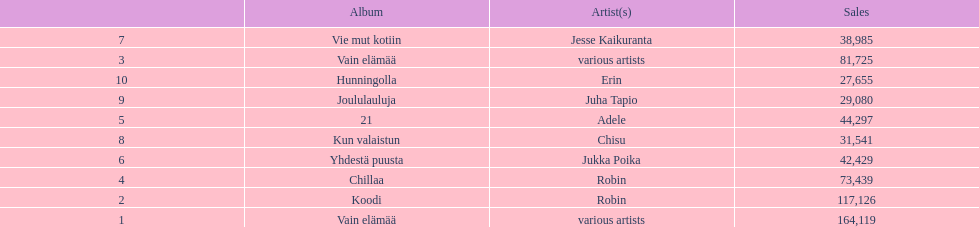How many albums sold for than 50,000 copies this year? 4. 